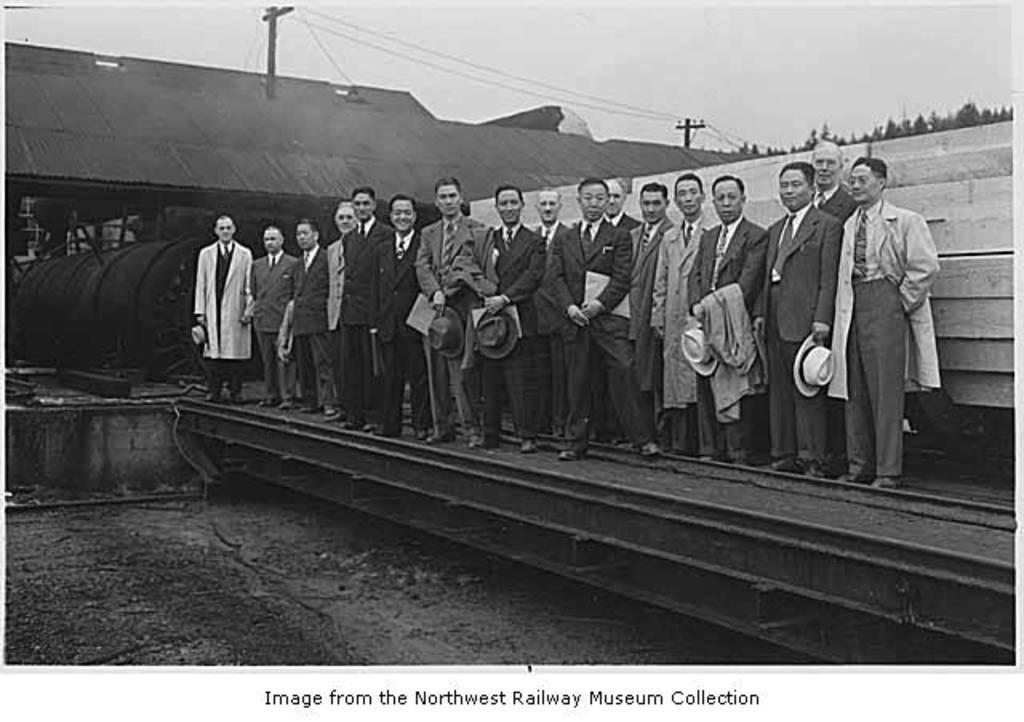Could you give a brief overview of what you see in this image? This is a black and white image. There are people standing. In the background of the image there is train engine. There is a shed. There are trees. There are electric poles. 